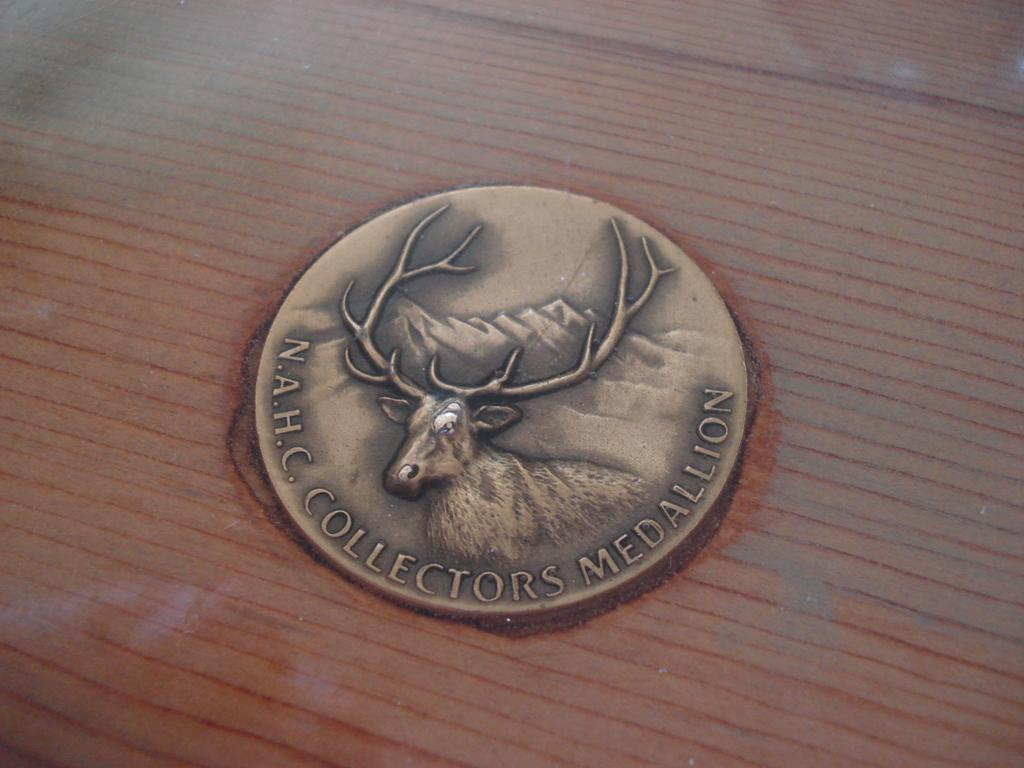What is the main subject of the image? The main subject of the image is a badge. What is depicted on the badge? The badge contains mountains and an antelope. Is there any text on the badge? Yes, there is text on the badge. What type of punishment is being administered in the image? There is no punishment being administered in the image; it features a badge with mountains, an antelope, and text. What action is the antelope taking in the image? The image does not depict the antelope taking any action; it is a static image of a badge. 